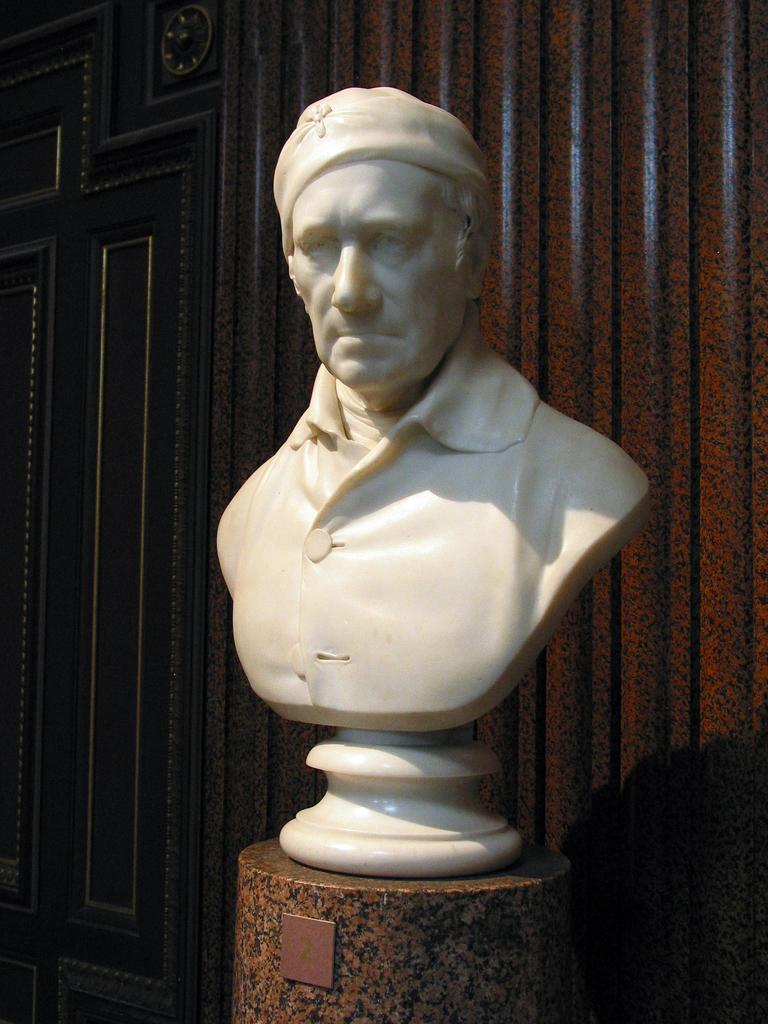What is the main subject in the center of the image? There is a statue in the center of the image. Where is the statue located? The statue is placed on a table. What can be seen in the background of the image? There is a wall in the background of the image. What year is the van parked next to the statue in the image? There is no van present in the image, so it is not possible to determine the year it might be parked next to the statue. 